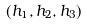<formula> <loc_0><loc_0><loc_500><loc_500>( h _ { 1 } , h _ { 2 } , h _ { 3 } )</formula> 